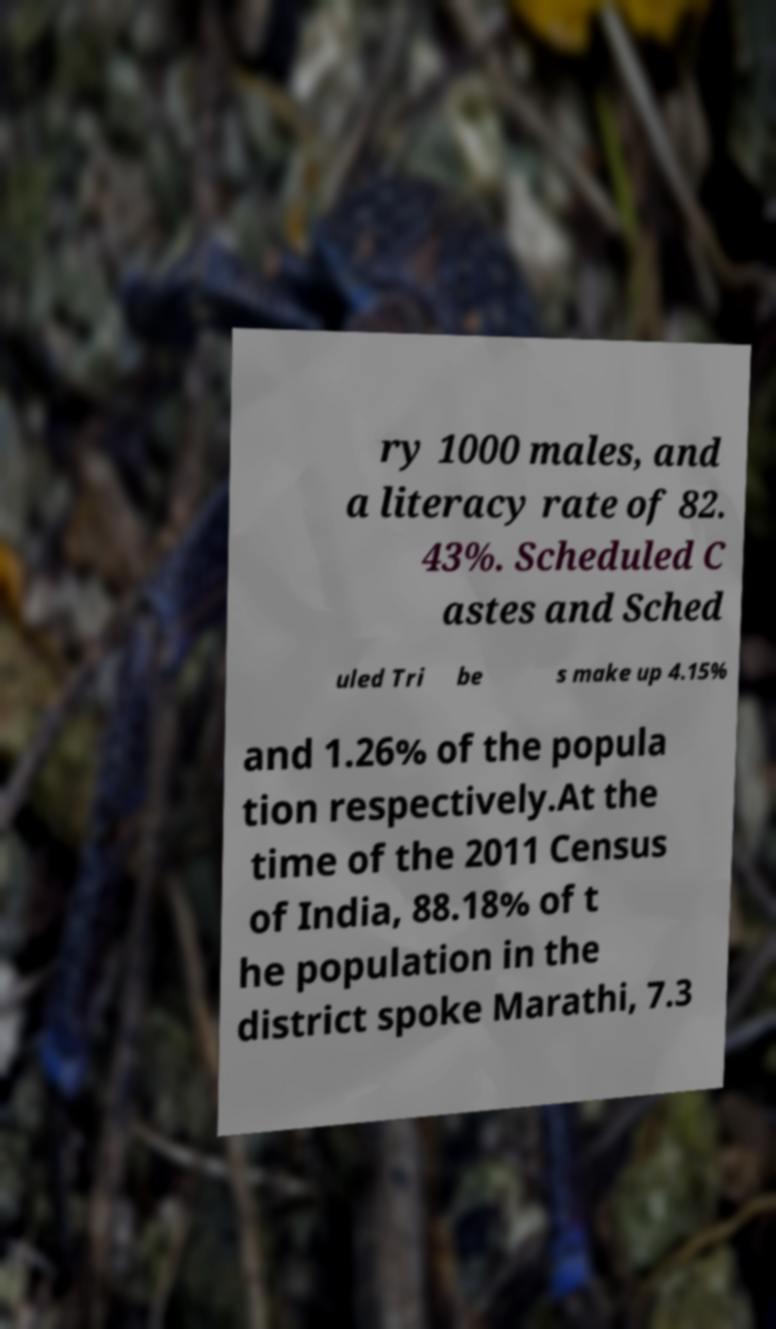Can you read and provide the text displayed in the image?This photo seems to have some interesting text. Can you extract and type it out for me? ry 1000 males, and a literacy rate of 82. 43%. Scheduled C astes and Sched uled Tri be s make up 4.15% and 1.26% of the popula tion respectively.At the time of the 2011 Census of India, 88.18% of t he population in the district spoke Marathi, 7.3 